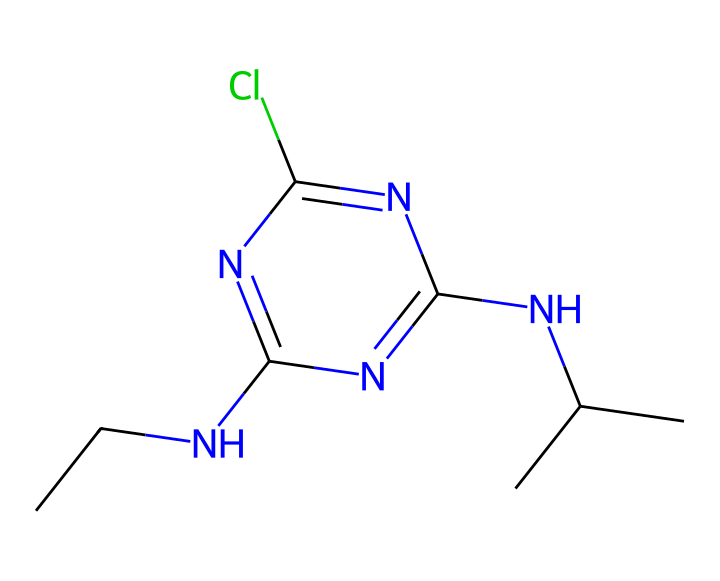How many nitrogen atoms are in this chemical? By examining the SMILES representation, we can count the nitrogen atoms present in the structure. There are three 'N' symbols in the SMILES which indicate three nitrogen atoms in the compound.
Answer: three What is the primary functional group in this herbicide? The chemical structure includes a cyanamide group indicated by the presence of 'CNC' where 'N' is directly bonded to 'C'. This suggests the presence of a functional group related to amines or substituted amines.
Answer: cyanamide How many chlorine atoms are present? Looking at the SMILES notation, there is one 'Cl' which signifies the presence of one chlorine atom in the chemical structure.
Answer: one Is this herbicide likely to be a selective or non-selective herbicide? Based on the chemical structure, atrazine is known for its selective properties, primarily affecting certain weed species rather than all plants.
Answer: selective What is the main mechanism of action of atrazine? The herbicide atrazine typically works by inhibiting photosynthesis through blockade of the photosystem II in plants, interfering with their ability to convert sunlight into energy.
Answer: photosynthesis inhibition What do the two 'C' at the end of the SMILES suggest about the structure? The two 'C' indicate the presence of isopropyl groups in the molecule, contributing to its lipophilicity and overall herbicidal properties.
Answer: isopropyl groups Does this herbicide pose any risk to aquatic environments? Yes, atrazine has been associated with runoff into water bodies, leading to contamination and potential harm to aquatic ecosystems.
Answer: yes 